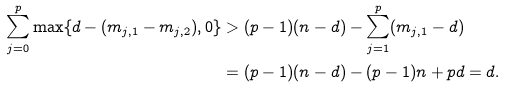Convert formula to latex. <formula><loc_0><loc_0><loc_500><loc_500>\sum _ { j = 0 } ^ { p } \max \{ d - ( m _ { j , 1 } - m _ { j , 2 } ) , 0 \} & > ( p - 1 ) ( n - d ) - \sum _ { j = 1 } ^ { p } ( m _ { j , 1 } - d ) \\ & = ( p - 1 ) ( n - d ) - ( p - 1 ) n + p d = d .</formula> 